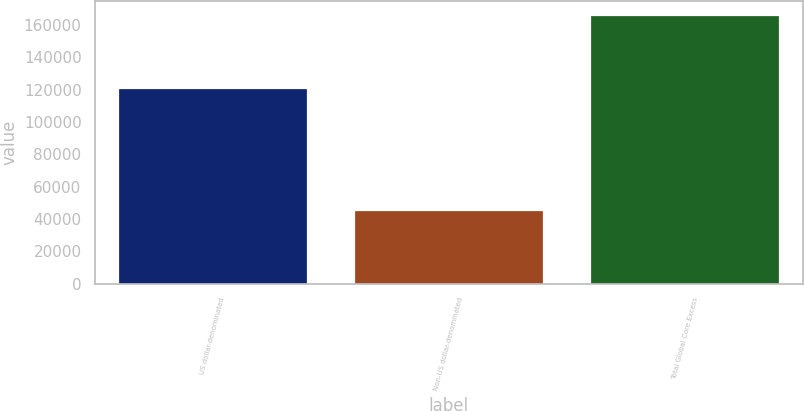<chart> <loc_0><loc_0><loc_500><loc_500><bar_chart><fcel>US dollar-denominated<fcel>Non-US dollar-denominated<fcel>Total Global Core Excess<nl><fcel>120970<fcel>45404<fcel>166374<nl></chart> 